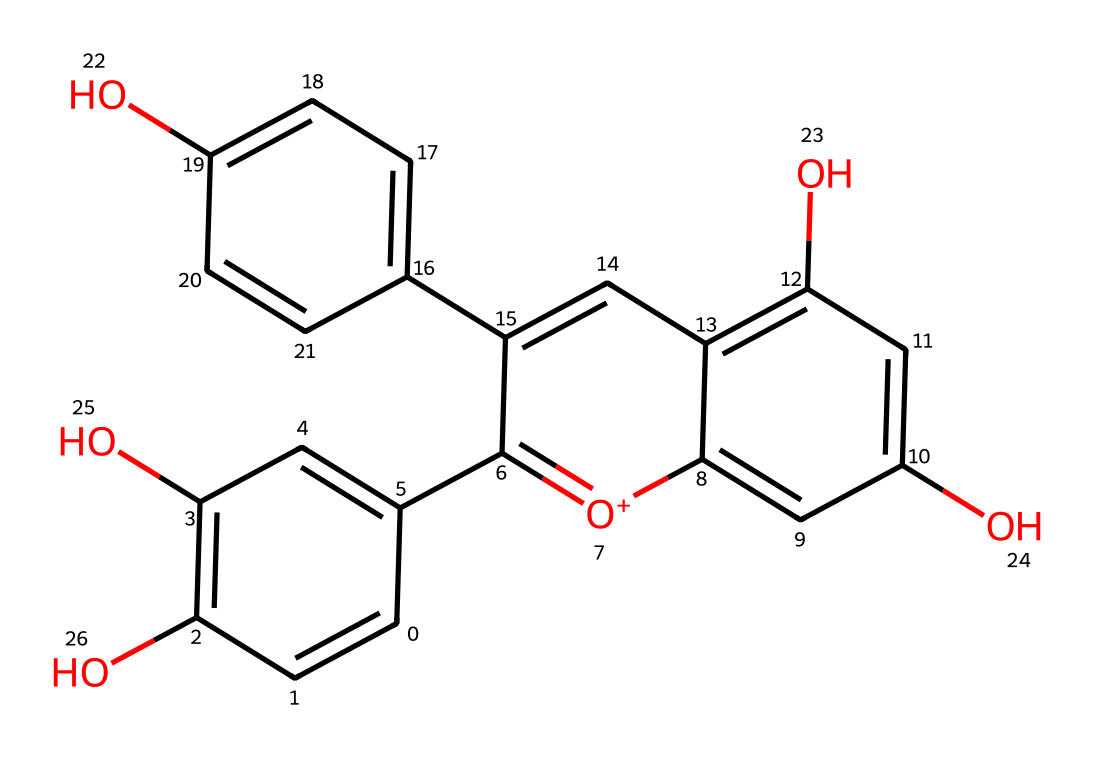How many hydroxyl groups are present in this chemical? By examining the structure represented by the SMILES notation, we can look for the -OH groups, which are characteristic of hydroxyl functional groups. There are four -OH groups (hydroxyl groups) present in this chemical structure.
Answer: four What is the molecular formula of this chemical? By interpreting the SMILES representation, we can count the number of carbon (C), hydrogen (H), and oxygen (O) atoms. This chemical contains 15 carbons, 11 hydrogens, and 6 oxygens, leading to the molecular formula C15H11O6.
Answer: C15H11O6 Which part of this chemical contributes to its deep color? The chemical structure contains several conjugated double bonds and hydroxyl groups, which contribute to its deep color by allowing for the absorption of visible light. Specifically, the extended conjugation in the aromatic rings is crucial for its color.
Answer: conjugated double bonds Is this chemical a type of flavonoid? The structure indicates that it contains multiple phenolic hydroxyl groups and is derived from a flavonoid base, which is characteristic of anthocyanins that typically belong to this class.
Answer: yes What role does this chemical play in Primitivo wine? This chemical, as an anthocyanin, provides the pigment that gives the Primitivo wine its characteristic deep red color, influencing appearance and potentially some flavor notes.
Answer: pigment How many rings are present in this chemical structure? By analyzing the structure, we can see that there are three cyclic structures (rings) present in this chemical, which contributes to its overall stability and features.
Answer: three 